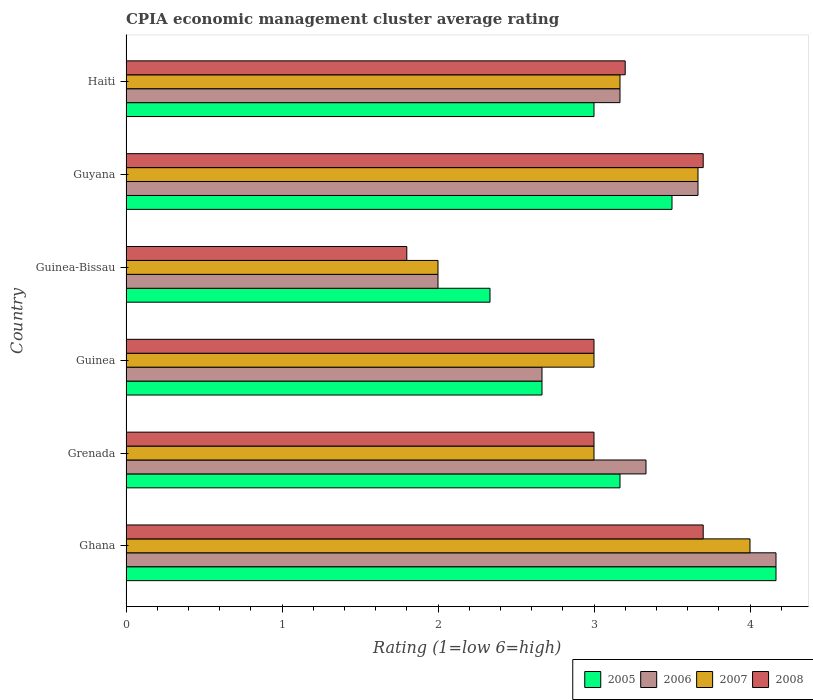How many different coloured bars are there?
Give a very brief answer. 4. How many groups of bars are there?
Offer a very short reply. 6. What is the label of the 6th group of bars from the top?
Provide a short and direct response. Ghana. In how many cases, is the number of bars for a given country not equal to the number of legend labels?
Ensure brevity in your answer.  0. Across all countries, what is the maximum CPIA rating in 2006?
Your answer should be compact. 4.17. Across all countries, what is the minimum CPIA rating in 2006?
Offer a terse response. 2. In which country was the CPIA rating in 2007 maximum?
Keep it short and to the point. Ghana. In which country was the CPIA rating in 2006 minimum?
Your answer should be compact. Guinea-Bissau. What is the difference between the CPIA rating in 2007 in Ghana and that in Guinea-Bissau?
Offer a terse response. 2. What is the difference between the CPIA rating in 2008 in Ghana and the CPIA rating in 2007 in Guinea-Bissau?
Your response must be concise. 1.7. What is the average CPIA rating in 2007 per country?
Provide a short and direct response. 3.14. What is the difference between the CPIA rating in 2008 and CPIA rating in 2007 in Grenada?
Keep it short and to the point. 0. In how many countries, is the CPIA rating in 2008 greater than 3 ?
Provide a succinct answer. 3. What is the difference between the highest and the second highest CPIA rating in 2007?
Offer a terse response. 0.33. What is the difference between the highest and the lowest CPIA rating in 2006?
Keep it short and to the point. 2.17. Is the sum of the CPIA rating in 2006 in Ghana and Guinea-Bissau greater than the maximum CPIA rating in 2005 across all countries?
Give a very brief answer. Yes. Are all the bars in the graph horizontal?
Make the answer very short. Yes. What is the difference between two consecutive major ticks on the X-axis?
Give a very brief answer. 1. Are the values on the major ticks of X-axis written in scientific E-notation?
Your answer should be compact. No. Does the graph contain grids?
Your answer should be compact. No. Where does the legend appear in the graph?
Keep it short and to the point. Bottom right. How are the legend labels stacked?
Your response must be concise. Horizontal. What is the title of the graph?
Offer a terse response. CPIA economic management cluster average rating. Does "2009" appear as one of the legend labels in the graph?
Your response must be concise. No. What is the Rating (1=low 6=high) in 2005 in Ghana?
Provide a short and direct response. 4.17. What is the Rating (1=low 6=high) of 2006 in Ghana?
Keep it short and to the point. 4.17. What is the Rating (1=low 6=high) of 2007 in Ghana?
Provide a short and direct response. 4. What is the Rating (1=low 6=high) of 2005 in Grenada?
Make the answer very short. 3.17. What is the Rating (1=low 6=high) of 2006 in Grenada?
Ensure brevity in your answer.  3.33. What is the Rating (1=low 6=high) in 2007 in Grenada?
Your response must be concise. 3. What is the Rating (1=low 6=high) of 2005 in Guinea?
Your answer should be compact. 2.67. What is the Rating (1=low 6=high) of 2006 in Guinea?
Give a very brief answer. 2.67. What is the Rating (1=low 6=high) of 2007 in Guinea?
Ensure brevity in your answer.  3. What is the Rating (1=low 6=high) in 2005 in Guinea-Bissau?
Make the answer very short. 2.33. What is the Rating (1=low 6=high) in 2006 in Guinea-Bissau?
Provide a short and direct response. 2. What is the Rating (1=low 6=high) of 2006 in Guyana?
Offer a terse response. 3.67. What is the Rating (1=low 6=high) in 2007 in Guyana?
Ensure brevity in your answer.  3.67. What is the Rating (1=low 6=high) of 2005 in Haiti?
Make the answer very short. 3. What is the Rating (1=low 6=high) in 2006 in Haiti?
Your response must be concise. 3.17. What is the Rating (1=low 6=high) of 2007 in Haiti?
Offer a very short reply. 3.17. Across all countries, what is the maximum Rating (1=low 6=high) in 2005?
Offer a terse response. 4.17. Across all countries, what is the maximum Rating (1=low 6=high) of 2006?
Keep it short and to the point. 4.17. Across all countries, what is the minimum Rating (1=low 6=high) in 2005?
Provide a succinct answer. 2.33. Across all countries, what is the minimum Rating (1=low 6=high) of 2007?
Provide a short and direct response. 2. Across all countries, what is the minimum Rating (1=low 6=high) in 2008?
Give a very brief answer. 1.8. What is the total Rating (1=low 6=high) in 2005 in the graph?
Your response must be concise. 18.83. What is the total Rating (1=low 6=high) in 2007 in the graph?
Provide a short and direct response. 18.83. What is the total Rating (1=low 6=high) of 2008 in the graph?
Ensure brevity in your answer.  18.4. What is the difference between the Rating (1=low 6=high) in 2005 in Ghana and that in Grenada?
Provide a succinct answer. 1. What is the difference between the Rating (1=low 6=high) in 2007 in Ghana and that in Grenada?
Keep it short and to the point. 1. What is the difference between the Rating (1=low 6=high) in 2008 in Ghana and that in Grenada?
Make the answer very short. 0.7. What is the difference between the Rating (1=low 6=high) in 2005 in Ghana and that in Guinea?
Your answer should be compact. 1.5. What is the difference between the Rating (1=low 6=high) of 2007 in Ghana and that in Guinea?
Provide a short and direct response. 1. What is the difference between the Rating (1=low 6=high) of 2008 in Ghana and that in Guinea?
Provide a succinct answer. 0.7. What is the difference between the Rating (1=low 6=high) of 2005 in Ghana and that in Guinea-Bissau?
Give a very brief answer. 1.83. What is the difference between the Rating (1=low 6=high) of 2006 in Ghana and that in Guinea-Bissau?
Your answer should be very brief. 2.17. What is the difference between the Rating (1=low 6=high) of 2008 in Ghana and that in Guinea-Bissau?
Give a very brief answer. 1.9. What is the difference between the Rating (1=low 6=high) of 2005 in Ghana and that in Guyana?
Provide a short and direct response. 0.67. What is the difference between the Rating (1=low 6=high) of 2008 in Ghana and that in Guyana?
Ensure brevity in your answer.  0. What is the difference between the Rating (1=low 6=high) in 2005 in Ghana and that in Haiti?
Provide a succinct answer. 1.17. What is the difference between the Rating (1=low 6=high) in 2006 in Ghana and that in Haiti?
Offer a terse response. 1. What is the difference between the Rating (1=low 6=high) of 2007 in Ghana and that in Haiti?
Your answer should be compact. 0.83. What is the difference between the Rating (1=low 6=high) of 2008 in Ghana and that in Haiti?
Your response must be concise. 0.5. What is the difference between the Rating (1=low 6=high) of 2005 in Grenada and that in Guinea?
Your answer should be compact. 0.5. What is the difference between the Rating (1=low 6=high) in 2007 in Grenada and that in Guinea?
Ensure brevity in your answer.  0. What is the difference between the Rating (1=low 6=high) in 2008 in Grenada and that in Guinea?
Your answer should be compact. 0. What is the difference between the Rating (1=low 6=high) in 2006 in Grenada and that in Guinea-Bissau?
Give a very brief answer. 1.33. What is the difference between the Rating (1=low 6=high) of 2008 in Grenada and that in Guinea-Bissau?
Your answer should be compact. 1.2. What is the difference between the Rating (1=low 6=high) of 2006 in Grenada and that in Guyana?
Make the answer very short. -0.33. What is the difference between the Rating (1=low 6=high) of 2007 in Grenada and that in Guyana?
Provide a short and direct response. -0.67. What is the difference between the Rating (1=low 6=high) in 2005 in Grenada and that in Haiti?
Provide a succinct answer. 0.17. What is the difference between the Rating (1=low 6=high) of 2007 in Grenada and that in Haiti?
Keep it short and to the point. -0.17. What is the difference between the Rating (1=low 6=high) of 2006 in Guinea and that in Guinea-Bissau?
Keep it short and to the point. 0.67. What is the difference between the Rating (1=low 6=high) in 2005 in Guinea and that in Haiti?
Give a very brief answer. -0.33. What is the difference between the Rating (1=low 6=high) of 2008 in Guinea and that in Haiti?
Provide a short and direct response. -0.2. What is the difference between the Rating (1=low 6=high) in 2005 in Guinea-Bissau and that in Guyana?
Offer a terse response. -1.17. What is the difference between the Rating (1=low 6=high) in 2006 in Guinea-Bissau and that in Guyana?
Give a very brief answer. -1.67. What is the difference between the Rating (1=low 6=high) of 2007 in Guinea-Bissau and that in Guyana?
Keep it short and to the point. -1.67. What is the difference between the Rating (1=low 6=high) in 2008 in Guinea-Bissau and that in Guyana?
Ensure brevity in your answer.  -1.9. What is the difference between the Rating (1=low 6=high) of 2005 in Guinea-Bissau and that in Haiti?
Offer a very short reply. -0.67. What is the difference between the Rating (1=low 6=high) of 2006 in Guinea-Bissau and that in Haiti?
Keep it short and to the point. -1.17. What is the difference between the Rating (1=low 6=high) of 2007 in Guinea-Bissau and that in Haiti?
Your response must be concise. -1.17. What is the difference between the Rating (1=low 6=high) of 2008 in Guyana and that in Haiti?
Keep it short and to the point. 0.5. What is the difference between the Rating (1=low 6=high) of 2005 in Ghana and the Rating (1=low 6=high) of 2007 in Grenada?
Your answer should be compact. 1.17. What is the difference between the Rating (1=low 6=high) of 2005 in Ghana and the Rating (1=low 6=high) of 2008 in Grenada?
Keep it short and to the point. 1.17. What is the difference between the Rating (1=low 6=high) of 2006 in Ghana and the Rating (1=low 6=high) of 2008 in Grenada?
Your answer should be very brief. 1.17. What is the difference between the Rating (1=low 6=high) of 2007 in Ghana and the Rating (1=low 6=high) of 2008 in Grenada?
Your answer should be very brief. 1. What is the difference between the Rating (1=low 6=high) in 2005 in Ghana and the Rating (1=low 6=high) in 2006 in Guinea?
Offer a very short reply. 1.5. What is the difference between the Rating (1=low 6=high) of 2005 in Ghana and the Rating (1=low 6=high) of 2007 in Guinea?
Provide a short and direct response. 1.17. What is the difference between the Rating (1=low 6=high) of 2006 in Ghana and the Rating (1=low 6=high) of 2008 in Guinea?
Offer a very short reply. 1.17. What is the difference between the Rating (1=low 6=high) of 2005 in Ghana and the Rating (1=low 6=high) of 2006 in Guinea-Bissau?
Give a very brief answer. 2.17. What is the difference between the Rating (1=low 6=high) of 2005 in Ghana and the Rating (1=low 6=high) of 2007 in Guinea-Bissau?
Offer a very short reply. 2.17. What is the difference between the Rating (1=low 6=high) of 2005 in Ghana and the Rating (1=low 6=high) of 2008 in Guinea-Bissau?
Your answer should be very brief. 2.37. What is the difference between the Rating (1=low 6=high) of 2006 in Ghana and the Rating (1=low 6=high) of 2007 in Guinea-Bissau?
Provide a short and direct response. 2.17. What is the difference between the Rating (1=low 6=high) of 2006 in Ghana and the Rating (1=low 6=high) of 2008 in Guinea-Bissau?
Provide a short and direct response. 2.37. What is the difference between the Rating (1=low 6=high) in 2007 in Ghana and the Rating (1=low 6=high) in 2008 in Guinea-Bissau?
Offer a terse response. 2.2. What is the difference between the Rating (1=low 6=high) in 2005 in Ghana and the Rating (1=low 6=high) in 2006 in Guyana?
Your response must be concise. 0.5. What is the difference between the Rating (1=low 6=high) in 2005 in Ghana and the Rating (1=low 6=high) in 2008 in Guyana?
Provide a short and direct response. 0.47. What is the difference between the Rating (1=low 6=high) in 2006 in Ghana and the Rating (1=low 6=high) in 2008 in Guyana?
Your answer should be compact. 0.47. What is the difference between the Rating (1=low 6=high) in 2005 in Ghana and the Rating (1=low 6=high) in 2006 in Haiti?
Your answer should be very brief. 1. What is the difference between the Rating (1=low 6=high) in 2005 in Ghana and the Rating (1=low 6=high) in 2007 in Haiti?
Ensure brevity in your answer.  1. What is the difference between the Rating (1=low 6=high) of 2005 in Ghana and the Rating (1=low 6=high) of 2008 in Haiti?
Your answer should be very brief. 0.97. What is the difference between the Rating (1=low 6=high) of 2006 in Ghana and the Rating (1=low 6=high) of 2008 in Haiti?
Make the answer very short. 0.97. What is the difference between the Rating (1=low 6=high) of 2007 in Ghana and the Rating (1=low 6=high) of 2008 in Haiti?
Offer a terse response. 0.8. What is the difference between the Rating (1=low 6=high) of 2005 in Grenada and the Rating (1=low 6=high) of 2007 in Guinea?
Give a very brief answer. 0.17. What is the difference between the Rating (1=low 6=high) in 2005 in Grenada and the Rating (1=low 6=high) in 2008 in Guinea?
Your response must be concise. 0.17. What is the difference between the Rating (1=low 6=high) of 2006 in Grenada and the Rating (1=low 6=high) of 2008 in Guinea?
Your response must be concise. 0.33. What is the difference between the Rating (1=low 6=high) of 2005 in Grenada and the Rating (1=low 6=high) of 2006 in Guinea-Bissau?
Keep it short and to the point. 1.17. What is the difference between the Rating (1=low 6=high) of 2005 in Grenada and the Rating (1=low 6=high) of 2008 in Guinea-Bissau?
Give a very brief answer. 1.37. What is the difference between the Rating (1=low 6=high) of 2006 in Grenada and the Rating (1=low 6=high) of 2008 in Guinea-Bissau?
Give a very brief answer. 1.53. What is the difference between the Rating (1=low 6=high) of 2007 in Grenada and the Rating (1=low 6=high) of 2008 in Guinea-Bissau?
Your answer should be compact. 1.2. What is the difference between the Rating (1=low 6=high) in 2005 in Grenada and the Rating (1=low 6=high) in 2007 in Guyana?
Offer a terse response. -0.5. What is the difference between the Rating (1=low 6=high) of 2005 in Grenada and the Rating (1=low 6=high) of 2008 in Guyana?
Your answer should be very brief. -0.53. What is the difference between the Rating (1=low 6=high) of 2006 in Grenada and the Rating (1=low 6=high) of 2007 in Guyana?
Your answer should be very brief. -0.33. What is the difference between the Rating (1=low 6=high) of 2006 in Grenada and the Rating (1=low 6=high) of 2008 in Guyana?
Offer a very short reply. -0.37. What is the difference between the Rating (1=low 6=high) in 2005 in Grenada and the Rating (1=low 6=high) in 2008 in Haiti?
Make the answer very short. -0.03. What is the difference between the Rating (1=low 6=high) in 2006 in Grenada and the Rating (1=low 6=high) in 2008 in Haiti?
Provide a succinct answer. 0.13. What is the difference between the Rating (1=low 6=high) of 2007 in Grenada and the Rating (1=low 6=high) of 2008 in Haiti?
Ensure brevity in your answer.  -0.2. What is the difference between the Rating (1=low 6=high) of 2005 in Guinea and the Rating (1=low 6=high) of 2008 in Guinea-Bissau?
Make the answer very short. 0.87. What is the difference between the Rating (1=low 6=high) in 2006 in Guinea and the Rating (1=low 6=high) in 2007 in Guinea-Bissau?
Offer a terse response. 0.67. What is the difference between the Rating (1=low 6=high) of 2006 in Guinea and the Rating (1=low 6=high) of 2008 in Guinea-Bissau?
Your answer should be very brief. 0.87. What is the difference between the Rating (1=low 6=high) of 2007 in Guinea and the Rating (1=low 6=high) of 2008 in Guinea-Bissau?
Give a very brief answer. 1.2. What is the difference between the Rating (1=low 6=high) in 2005 in Guinea and the Rating (1=low 6=high) in 2006 in Guyana?
Your answer should be very brief. -1. What is the difference between the Rating (1=low 6=high) of 2005 in Guinea and the Rating (1=low 6=high) of 2007 in Guyana?
Give a very brief answer. -1. What is the difference between the Rating (1=low 6=high) in 2005 in Guinea and the Rating (1=low 6=high) in 2008 in Guyana?
Make the answer very short. -1.03. What is the difference between the Rating (1=low 6=high) of 2006 in Guinea and the Rating (1=low 6=high) of 2007 in Guyana?
Offer a terse response. -1. What is the difference between the Rating (1=low 6=high) in 2006 in Guinea and the Rating (1=low 6=high) in 2008 in Guyana?
Give a very brief answer. -1.03. What is the difference between the Rating (1=low 6=high) in 2007 in Guinea and the Rating (1=low 6=high) in 2008 in Guyana?
Your response must be concise. -0.7. What is the difference between the Rating (1=low 6=high) in 2005 in Guinea and the Rating (1=low 6=high) in 2006 in Haiti?
Keep it short and to the point. -0.5. What is the difference between the Rating (1=low 6=high) of 2005 in Guinea and the Rating (1=low 6=high) of 2007 in Haiti?
Offer a terse response. -0.5. What is the difference between the Rating (1=low 6=high) of 2005 in Guinea and the Rating (1=low 6=high) of 2008 in Haiti?
Offer a terse response. -0.53. What is the difference between the Rating (1=low 6=high) of 2006 in Guinea and the Rating (1=low 6=high) of 2008 in Haiti?
Keep it short and to the point. -0.53. What is the difference between the Rating (1=low 6=high) of 2005 in Guinea-Bissau and the Rating (1=low 6=high) of 2006 in Guyana?
Give a very brief answer. -1.33. What is the difference between the Rating (1=low 6=high) of 2005 in Guinea-Bissau and the Rating (1=low 6=high) of 2007 in Guyana?
Keep it short and to the point. -1.33. What is the difference between the Rating (1=low 6=high) of 2005 in Guinea-Bissau and the Rating (1=low 6=high) of 2008 in Guyana?
Make the answer very short. -1.37. What is the difference between the Rating (1=low 6=high) in 2006 in Guinea-Bissau and the Rating (1=low 6=high) in 2007 in Guyana?
Your answer should be compact. -1.67. What is the difference between the Rating (1=low 6=high) in 2006 in Guinea-Bissau and the Rating (1=low 6=high) in 2008 in Guyana?
Your response must be concise. -1.7. What is the difference between the Rating (1=low 6=high) of 2007 in Guinea-Bissau and the Rating (1=low 6=high) of 2008 in Guyana?
Provide a short and direct response. -1.7. What is the difference between the Rating (1=low 6=high) of 2005 in Guinea-Bissau and the Rating (1=low 6=high) of 2007 in Haiti?
Your answer should be compact. -0.83. What is the difference between the Rating (1=low 6=high) in 2005 in Guinea-Bissau and the Rating (1=low 6=high) in 2008 in Haiti?
Your answer should be compact. -0.87. What is the difference between the Rating (1=low 6=high) of 2006 in Guinea-Bissau and the Rating (1=low 6=high) of 2007 in Haiti?
Keep it short and to the point. -1.17. What is the difference between the Rating (1=low 6=high) in 2007 in Guinea-Bissau and the Rating (1=low 6=high) in 2008 in Haiti?
Give a very brief answer. -1.2. What is the difference between the Rating (1=low 6=high) of 2005 in Guyana and the Rating (1=low 6=high) of 2007 in Haiti?
Give a very brief answer. 0.33. What is the difference between the Rating (1=low 6=high) in 2006 in Guyana and the Rating (1=low 6=high) in 2007 in Haiti?
Give a very brief answer. 0.5. What is the difference between the Rating (1=low 6=high) in 2006 in Guyana and the Rating (1=low 6=high) in 2008 in Haiti?
Offer a terse response. 0.47. What is the difference between the Rating (1=low 6=high) of 2007 in Guyana and the Rating (1=low 6=high) of 2008 in Haiti?
Your response must be concise. 0.47. What is the average Rating (1=low 6=high) in 2005 per country?
Offer a very short reply. 3.14. What is the average Rating (1=low 6=high) of 2006 per country?
Make the answer very short. 3.17. What is the average Rating (1=low 6=high) in 2007 per country?
Offer a very short reply. 3.14. What is the average Rating (1=low 6=high) in 2008 per country?
Your answer should be compact. 3.07. What is the difference between the Rating (1=low 6=high) in 2005 and Rating (1=low 6=high) in 2007 in Ghana?
Offer a very short reply. 0.17. What is the difference between the Rating (1=low 6=high) of 2005 and Rating (1=low 6=high) of 2008 in Ghana?
Offer a terse response. 0.47. What is the difference between the Rating (1=low 6=high) of 2006 and Rating (1=low 6=high) of 2008 in Ghana?
Provide a succinct answer. 0.47. What is the difference between the Rating (1=low 6=high) in 2005 and Rating (1=low 6=high) in 2006 in Grenada?
Make the answer very short. -0.17. What is the difference between the Rating (1=low 6=high) in 2006 and Rating (1=low 6=high) in 2007 in Grenada?
Provide a succinct answer. 0.33. What is the difference between the Rating (1=low 6=high) in 2007 and Rating (1=low 6=high) in 2008 in Grenada?
Make the answer very short. 0. What is the difference between the Rating (1=low 6=high) of 2005 and Rating (1=low 6=high) of 2006 in Guinea?
Provide a succinct answer. 0. What is the difference between the Rating (1=low 6=high) in 2005 and Rating (1=low 6=high) in 2007 in Guinea?
Provide a succinct answer. -0.33. What is the difference between the Rating (1=low 6=high) of 2005 and Rating (1=low 6=high) of 2008 in Guinea?
Give a very brief answer. -0.33. What is the difference between the Rating (1=low 6=high) of 2006 and Rating (1=low 6=high) of 2007 in Guinea?
Offer a terse response. -0.33. What is the difference between the Rating (1=low 6=high) in 2006 and Rating (1=low 6=high) in 2008 in Guinea?
Provide a short and direct response. -0.33. What is the difference between the Rating (1=low 6=high) of 2007 and Rating (1=low 6=high) of 2008 in Guinea?
Keep it short and to the point. 0. What is the difference between the Rating (1=low 6=high) in 2005 and Rating (1=low 6=high) in 2006 in Guinea-Bissau?
Your answer should be compact. 0.33. What is the difference between the Rating (1=low 6=high) of 2005 and Rating (1=low 6=high) of 2008 in Guinea-Bissau?
Provide a succinct answer. 0.53. What is the difference between the Rating (1=low 6=high) of 2007 and Rating (1=low 6=high) of 2008 in Guinea-Bissau?
Provide a short and direct response. 0.2. What is the difference between the Rating (1=low 6=high) of 2005 and Rating (1=low 6=high) of 2007 in Guyana?
Provide a succinct answer. -0.17. What is the difference between the Rating (1=low 6=high) of 2005 and Rating (1=low 6=high) of 2008 in Guyana?
Offer a terse response. -0.2. What is the difference between the Rating (1=low 6=high) in 2006 and Rating (1=low 6=high) in 2008 in Guyana?
Offer a very short reply. -0.03. What is the difference between the Rating (1=low 6=high) in 2007 and Rating (1=low 6=high) in 2008 in Guyana?
Ensure brevity in your answer.  -0.03. What is the difference between the Rating (1=low 6=high) in 2005 and Rating (1=low 6=high) in 2006 in Haiti?
Offer a terse response. -0.17. What is the difference between the Rating (1=low 6=high) in 2005 and Rating (1=low 6=high) in 2007 in Haiti?
Your answer should be very brief. -0.17. What is the difference between the Rating (1=low 6=high) in 2005 and Rating (1=low 6=high) in 2008 in Haiti?
Provide a succinct answer. -0.2. What is the difference between the Rating (1=low 6=high) in 2006 and Rating (1=low 6=high) in 2007 in Haiti?
Provide a succinct answer. 0. What is the difference between the Rating (1=low 6=high) in 2006 and Rating (1=low 6=high) in 2008 in Haiti?
Make the answer very short. -0.03. What is the difference between the Rating (1=low 6=high) in 2007 and Rating (1=low 6=high) in 2008 in Haiti?
Your answer should be very brief. -0.03. What is the ratio of the Rating (1=low 6=high) in 2005 in Ghana to that in Grenada?
Keep it short and to the point. 1.32. What is the ratio of the Rating (1=low 6=high) of 2007 in Ghana to that in Grenada?
Ensure brevity in your answer.  1.33. What is the ratio of the Rating (1=low 6=high) in 2008 in Ghana to that in Grenada?
Keep it short and to the point. 1.23. What is the ratio of the Rating (1=low 6=high) of 2005 in Ghana to that in Guinea?
Offer a very short reply. 1.56. What is the ratio of the Rating (1=low 6=high) of 2006 in Ghana to that in Guinea?
Keep it short and to the point. 1.56. What is the ratio of the Rating (1=low 6=high) of 2008 in Ghana to that in Guinea?
Your answer should be compact. 1.23. What is the ratio of the Rating (1=low 6=high) of 2005 in Ghana to that in Guinea-Bissau?
Offer a very short reply. 1.79. What is the ratio of the Rating (1=low 6=high) of 2006 in Ghana to that in Guinea-Bissau?
Ensure brevity in your answer.  2.08. What is the ratio of the Rating (1=low 6=high) in 2007 in Ghana to that in Guinea-Bissau?
Provide a short and direct response. 2. What is the ratio of the Rating (1=low 6=high) in 2008 in Ghana to that in Guinea-Bissau?
Ensure brevity in your answer.  2.06. What is the ratio of the Rating (1=low 6=high) of 2005 in Ghana to that in Guyana?
Your answer should be very brief. 1.19. What is the ratio of the Rating (1=low 6=high) in 2006 in Ghana to that in Guyana?
Provide a succinct answer. 1.14. What is the ratio of the Rating (1=low 6=high) in 2008 in Ghana to that in Guyana?
Your response must be concise. 1. What is the ratio of the Rating (1=low 6=high) in 2005 in Ghana to that in Haiti?
Provide a short and direct response. 1.39. What is the ratio of the Rating (1=low 6=high) of 2006 in Ghana to that in Haiti?
Provide a short and direct response. 1.32. What is the ratio of the Rating (1=low 6=high) in 2007 in Ghana to that in Haiti?
Keep it short and to the point. 1.26. What is the ratio of the Rating (1=low 6=high) of 2008 in Ghana to that in Haiti?
Your response must be concise. 1.16. What is the ratio of the Rating (1=low 6=high) in 2005 in Grenada to that in Guinea?
Offer a very short reply. 1.19. What is the ratio of the Rating (1=low 6=high) of 2005 in Grenada to that in Guinea-Bissau?
Your answer should be compact. 1.36. What is the ratio of the Rating (1=low 6=high) of 2006 in Grenada to that in Guinea-Bissau?
Your response must be concise. 1.67. What is the ratio of the Rating (1=low 6=high) in 2007 in Grenada to that in Guinea-Bissau?
Make the answer very short. 1.5. What is the ratio of the Rating (1=low 6=high) in 2005 in Grenada to that in Guyana?
Offer a terse response. 0.9. What is the ratio of the Rating (1=low 6=high) in 2006 in Grenada to that in Guyana?
Your response must be concise. 0.91. What is the ratio of the Rating (1=low 6=high) of 2007 in Grenada to that in Guyana?
Give a very brief answer. 0.82. What is the ratio of the Rating (1=low 6=high) of 2008 in Grenada to that in Guyana?
Provide a succinct answer. 0.81. What is the ratio of the Rating (1=low 6=high) in 2005 in Grenada to that in Haiti?
Your answer should be very brief. 1.06. What is the ratio of the Rating (1=low 6=high) of 2006 in Grenada to that in Haiti?
Give a very brief answer. 1.05. What is the ratio of the Rating (1=low 6=high) in 2007 in Grenada to that in Haiti?
Make the answer very short. 0.95. What is the ratio of the Rating (1=low 6=high) in 2005 in Guinea to that in Guinea-Bissau?
Offer a terse response. 1.14. What is the ratio of the Rating (1=low 6=high) in 2005 in Guinea to that in Guyana?
Provide a succinct answer. 0.76. What is the ratio of the Rating (1=low 6=high) of 2006 in Guinea to that in Guyana?
Your response must be concise. 0.73. What is the ratio of the Rating (1=low 6=high) in 2007 in Guinea to that in Guyana?
Provide a short and direct response. 0.82. What is the ratio of the Rating (1=low 6=high) of 2008 in Guinea to that in Guyana?
Your answer should be very brief. 0.81. What is the ratio of the Rating (1=low 6=high) of 2005 in Guinea to that in Haiti?
Ensure brevity in your answer.  0.89. What is the ratio of the Rating (1=low 6=high) of 2006 in Guinea to that in Haiti?
Ensure brevity in your answer.  0.84. What is the ratio of the Rating (1=low 6=high) in 2008 in Guinea to that in Haiti?
Offer a very short reply. 0.94. What is the ratio of the Rating (1=low 6=high) of 2005 in Guinea-Bissau to that in Guyana?
Ensure brevity in your answer.  0.67. What is the ratio of the Rating (1=low 6=high) in 2006 in Guinea-Bissau to that in Guyana?
Provide a succinct answer. 0.55. What is the ratio of the Rating (1=low 6=high) of 2007 in Guinea-Bissau to that in Guyana?
Your answer should be very brief. 0.55. What is the ratio of the Rating (1=low 6=high) of 2008 in Guinea-Bissau to that in Guyana?
Your answer should be compact. 0.49. What is the ratio of the Rating (1=low 6=high) in 2006 in Guinea-Bissau to that in Haiti?
Ensure brevity in your answer.  0.63. What is the ratio of the Rating (1=low 6=high) of 2007 in Guinea-Bissau to that in Haiti?
Ensure brevity in your answer.  0.63. What is the ratio of the Rating (1=low 6=high) in 2008 in Guinea-Bissau to that in Haiti?
Offer a terse response. 0.56. What is the ratio of the Rating (1=low 6=high) of 2005 in Guyana to that in Haiti?
Make the answer very short. 1.17. What is the ratio of the Rating (1=low 6=high) in 2006 in Guyana to that in Haiti?
Offer a very short reply. 1.16. What is the ratio of the Rating (1=low 6=high) of 2007 in Guyana to that in Haiti?
Provide a succinct answer. 1.16. What is the ratio of the Rating (1=low 6=high) in 2008 in Guyana to that in Haiti?
Offer a very short reply. 1.16. What is the difference between the highest and the second highest Rating (1=low 6=high) of 2005?
Give a very brief answer. 0.67. What is the difference between the highest and the second highest Rating (1=low 6=high) in 2008?
Make the answer very short. 0. What is the difference between the highest and the lowest Rating (1=low 6=high) of 2005?
Ensure brevity in your answer.  1.83. What is the difference between the highest and the lowest Rating (1=low 6=high) of 2006?
Your answer should be compact. 2.17. 